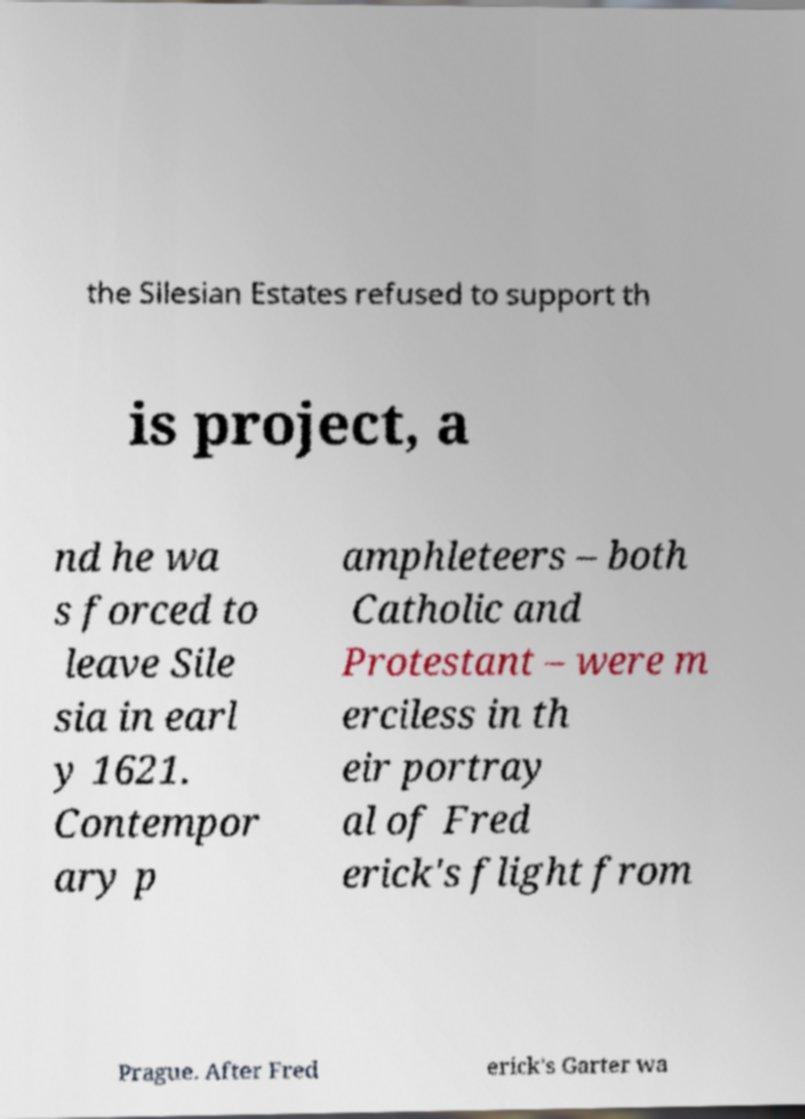There's text embedded in this image that I need extracted. Can you transcribe it verbatim? the Silesian Estates refused to support th is project, a nd he wa s forced to leave Sile sia in earl y 1621. Contempor ary p amphleteers – both Catholic and Protestant – were m erciless in th eir portray al of Fred erick's flight from Prague. After Fred erick's Garter wa 